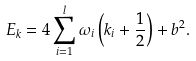Convert formula to latex. <formula><loc_0><loc_0><loc_500><loc_500>E _ { k } = 4 \sum _ { i = 1 } ^ { l } \omega _ { i } \left ( k _ { i } + \frac { 1 } { 2 } \right ) + b ^ { 2 } .</formula> 